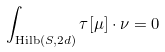Convert formula to latex. <formula><loc_0><loc_0><loc_500><loc_500>\int _ { { \text {Hilb} } ( S , 2 d ) } \tau [ \mu ] \cdot \nu = 0</formula> 